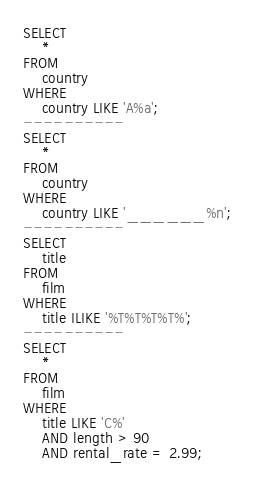Convert code to text. <code><loc_0><loc_0><loc_500><loc_500><_SQL_>SELECT
    *
FROM
    country
WHERE
    country LIKE 'A%a';
----------
SELECT
    *
FROM
    country
WHERE
    country LIKE '______%n';
----------
SELECT
    title
FROM
    film
WHERE
    title ILIKE '%T%T%T%T%';
----------
SELECT
    *
FROM
    film
WHERE
    title LIKE 'C%'
    AND length > 90
    AND rental_rate = 2.99;</code> 